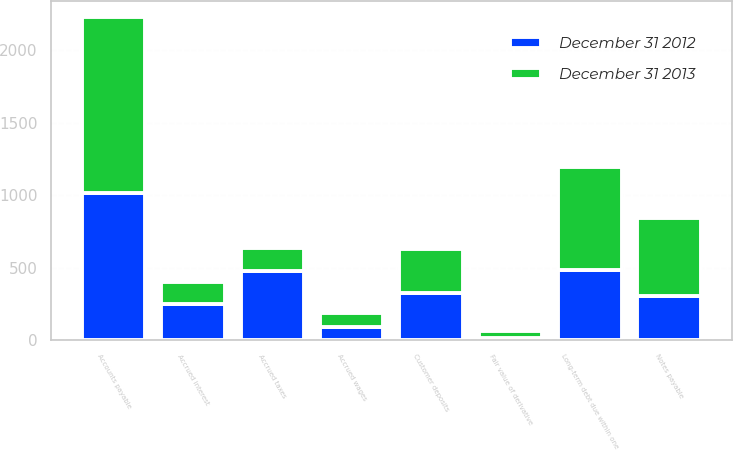<chart> <loc_0><loc_0><loc_500><loc_500><stacked_bar_chart><ecel><fcel>Long-term debt due within one<fcel>Notes payable<fcel>Accounts payable<fcel>Customer deposits<fcel>Accrued taxes<fcel>Accrued interest<fcel>Accrued wages<fcel>Fair value of derivative<nl><fcel>December 31 2012<fcel>485<fcel>304<fcel>1017<fcel>321<fcel>476<fcel>249<fcel>92<fcel>13<nl><fcel>December 31 2013<fcel>706<fcel>539<fcel>1215<fcel>304<fcel>162<fcel>153<fcel>94<fcel>47<nl></chart> 